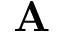Convert formula to latex. <formula><loc_0><loc_0><loc_500><loc_500>A</formula> 